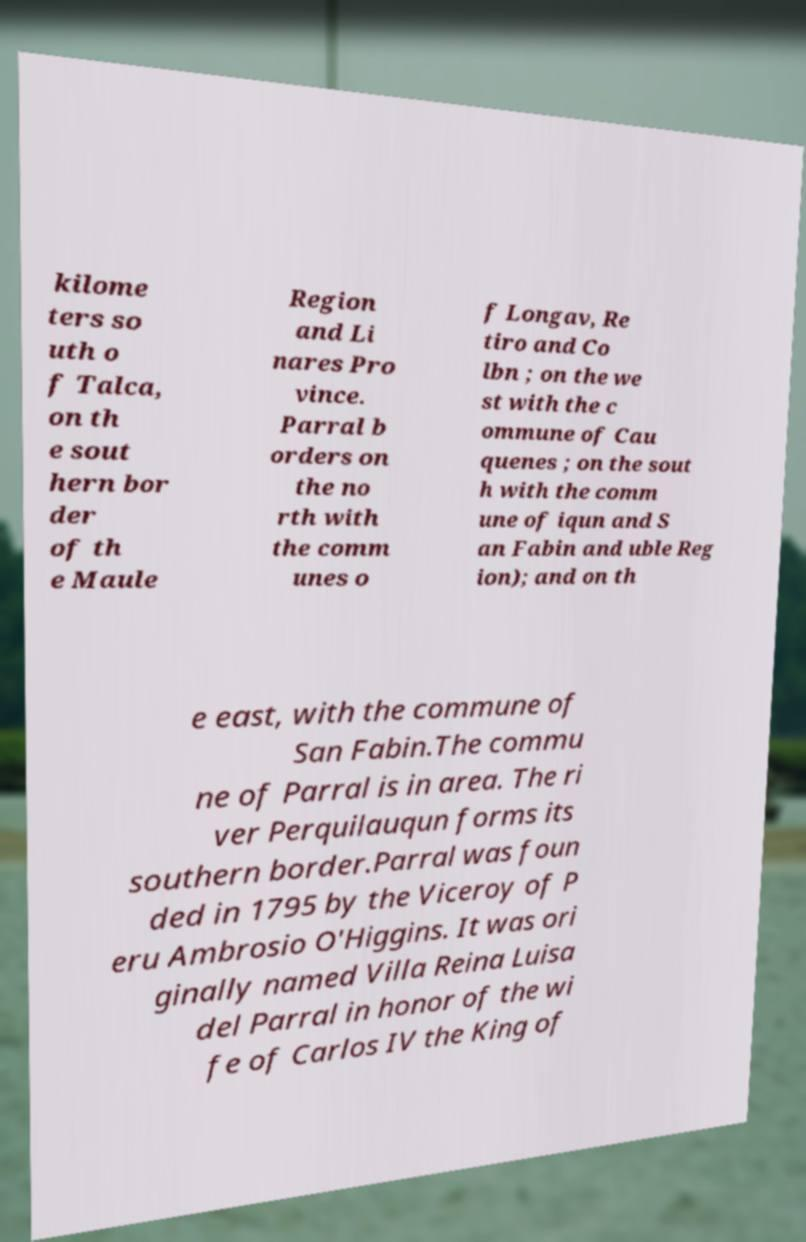I need the written content from this picture converted into text. Can you do that? kilome ters so uth o f Talca, on th e sout hern bor der of th e Maule Region and Li nares Pro vince. Parral b orders on the no rth with the comm unes o f Longav, Re tiro and Co lbn ; on the we st with the c ommune of Cau quenes ; on the sout h with the comm une of iqun and S an Fabin and uble Reg ion); and on th e east, with the commune of San Fabin.The commu ne of Parral is in area. The ri ver Perquilauqun forms its southern border.Parral was foun ded in 1795 by the Viceroy of P eru Ambrosio O'Higgins. It was ori ginally named Villa Reina Luisa del Parral in honor of the wi fe of Carlos IV the King of 